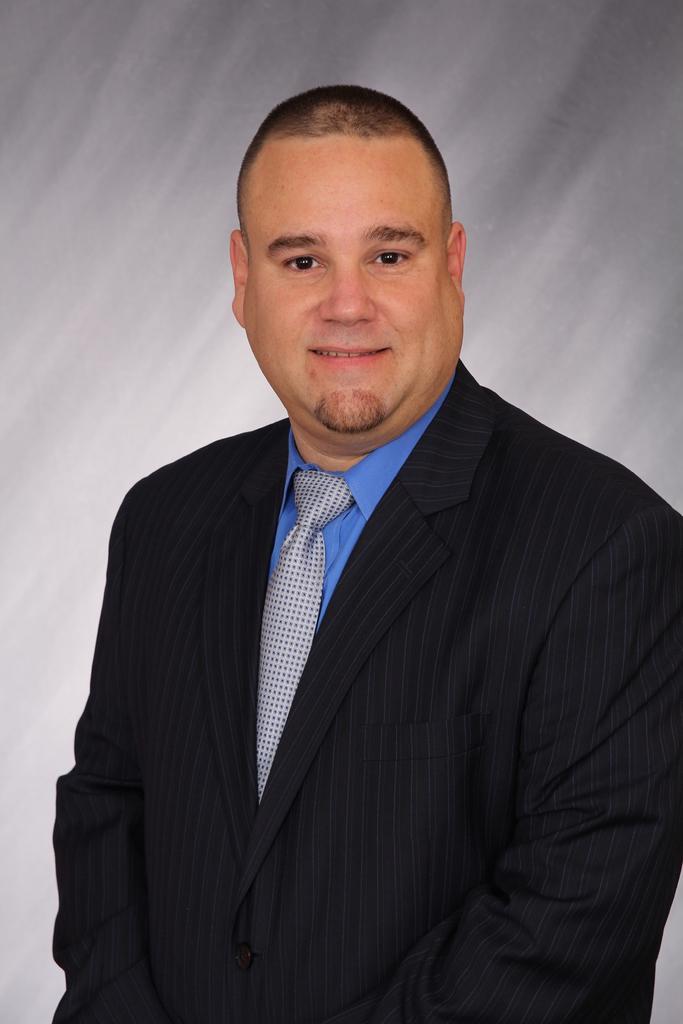Can you describe this image briefly? In this image the background is gray in color. In the middle of the image there is a man with a smiling face. 